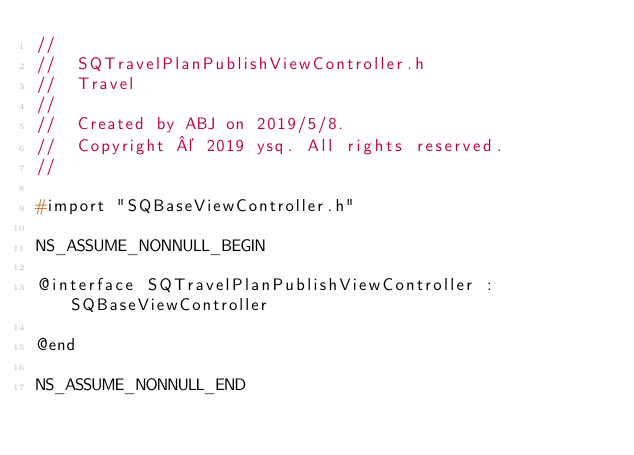Convert code to text. <code><loc_0><loc_0><loc_500><loc_500><_C_>//
//  SQTravelPlanPublishViewController.h
//  Travel
//
//  Created by ABJ on 2019/5/8.
//  Copyright © 2019 ysq. All rights reserved.
//

#import "SQBaseViewController.h"

NS_ASSUME_NONNULL_BEGIN

@interface SQTravelPlanPublishViewController : SQBaseViewController

@end

NS_ASSUME_NONNULL_END
</code> 